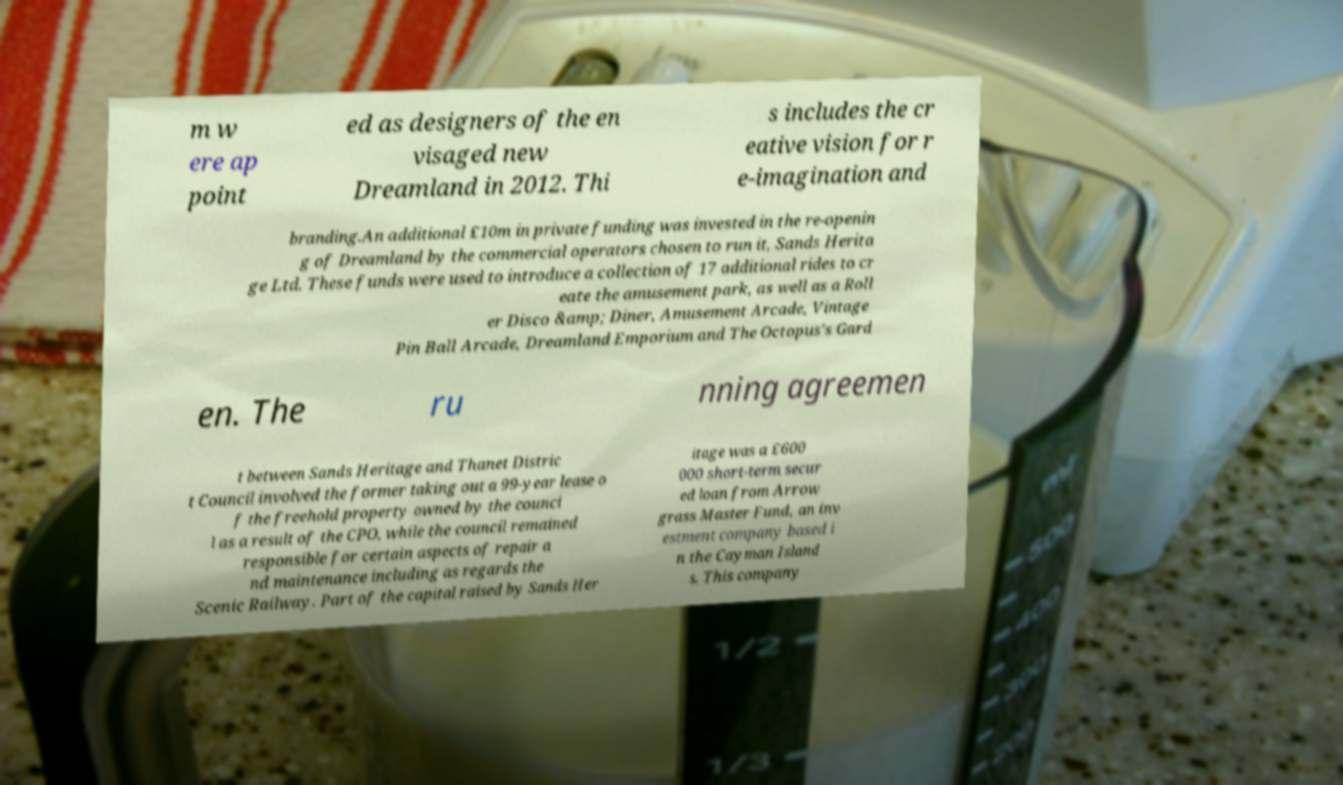There's text embedded in this image that I need extracted. Can you transcribe it verbatim? m w ere ap point ed as designers of the en visaged new Dreamland in 2012. Thi s includes the cr eative vision for r e-imagination and branding.An additional £10m in private funding was invested in the re-openin g of Dreamland by the commercial operators chosen to run it, Sands Herita ge Ltd. These funds were used to introduce a collection of 17 additional rides to cr eate the amusement park, as well as a Roll er Disco &amp; Diner, Amusement Arcade, Vintage Pin Ball Arcade, Dreamland Emporium and The Octopus's Gard en. The ru nning agreemen t between Sands Heritage and Thanet Distric t Council involved the former taking out a 99-year lease o f the freehold property owned by the counci l as a result of the CPO, while the council remained responsible for certain aspects of repair a nd maintenance including as regards the Scenic Railway. Part of the capital raised by Sands Her itage was a £600 000 short-term secur ed loan from Arrow grass Master Fund, an inv estment company based i n the Cayman Island s. This company 